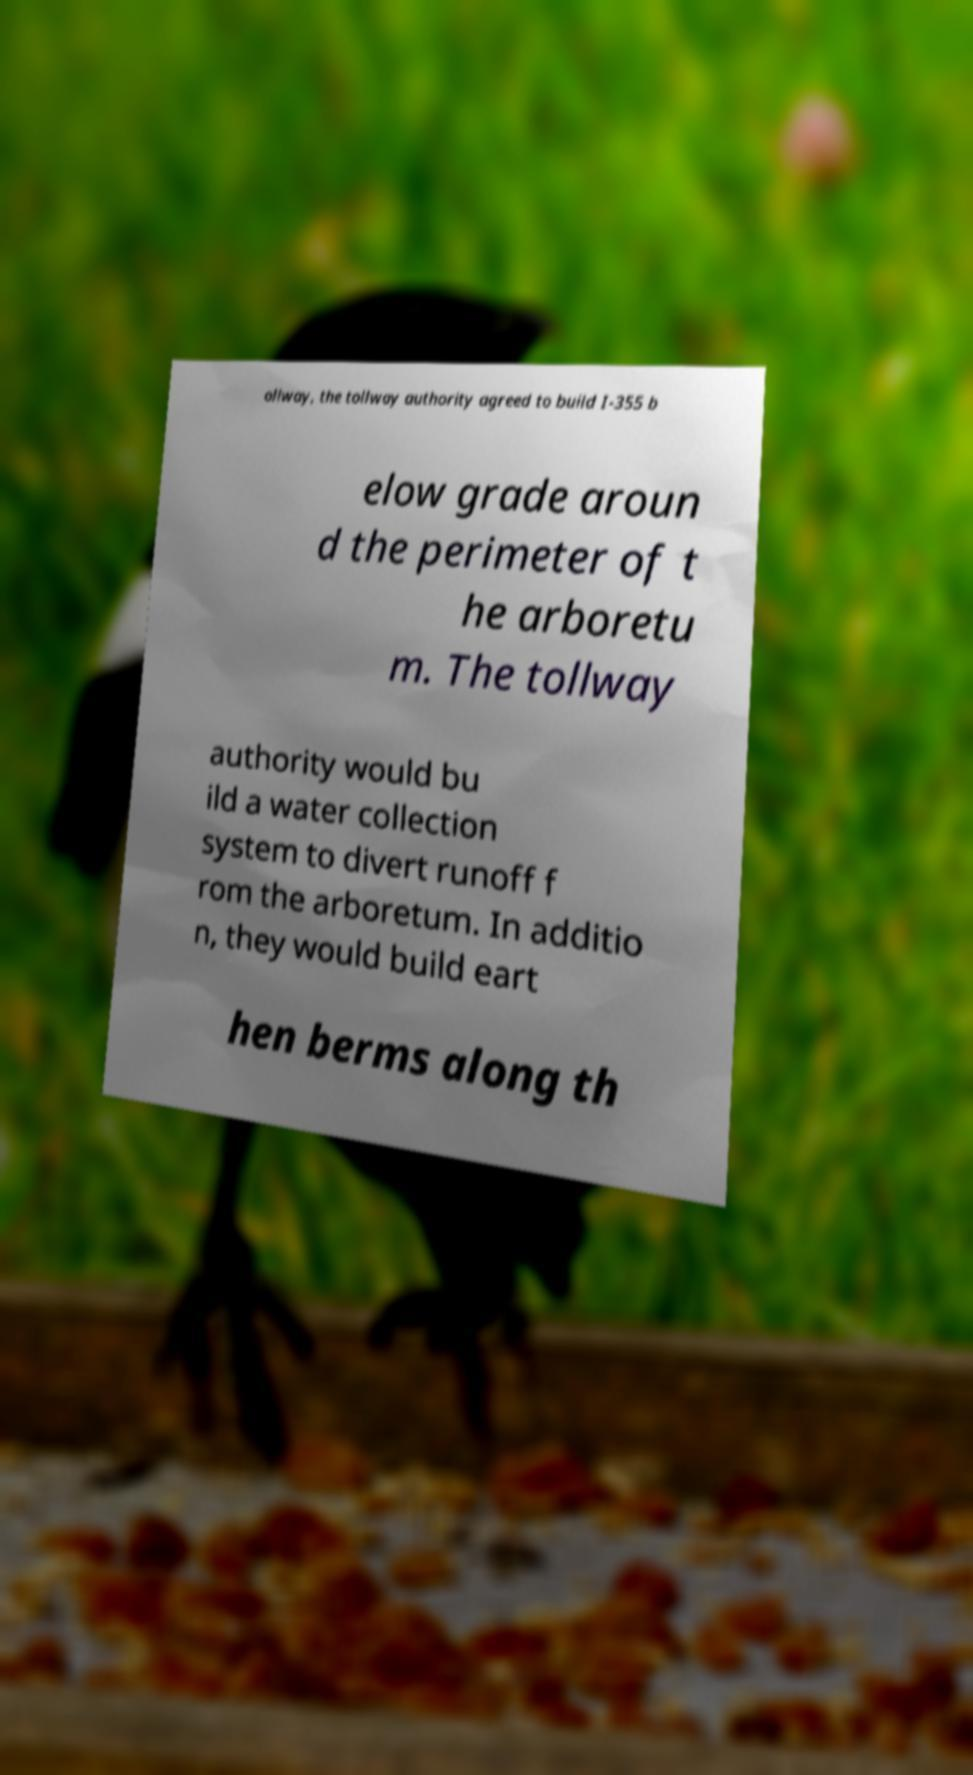Please read and relay the text visible in this image. What does it say? ollway, the tollway authority agreed to build I-355 b elow grade aroun d the perimeter of t he arboretu m. The tollway authority would bu ild a water collection system to divert runoff f rom the arboretum. In additio n, they would build eart hen berms along th 